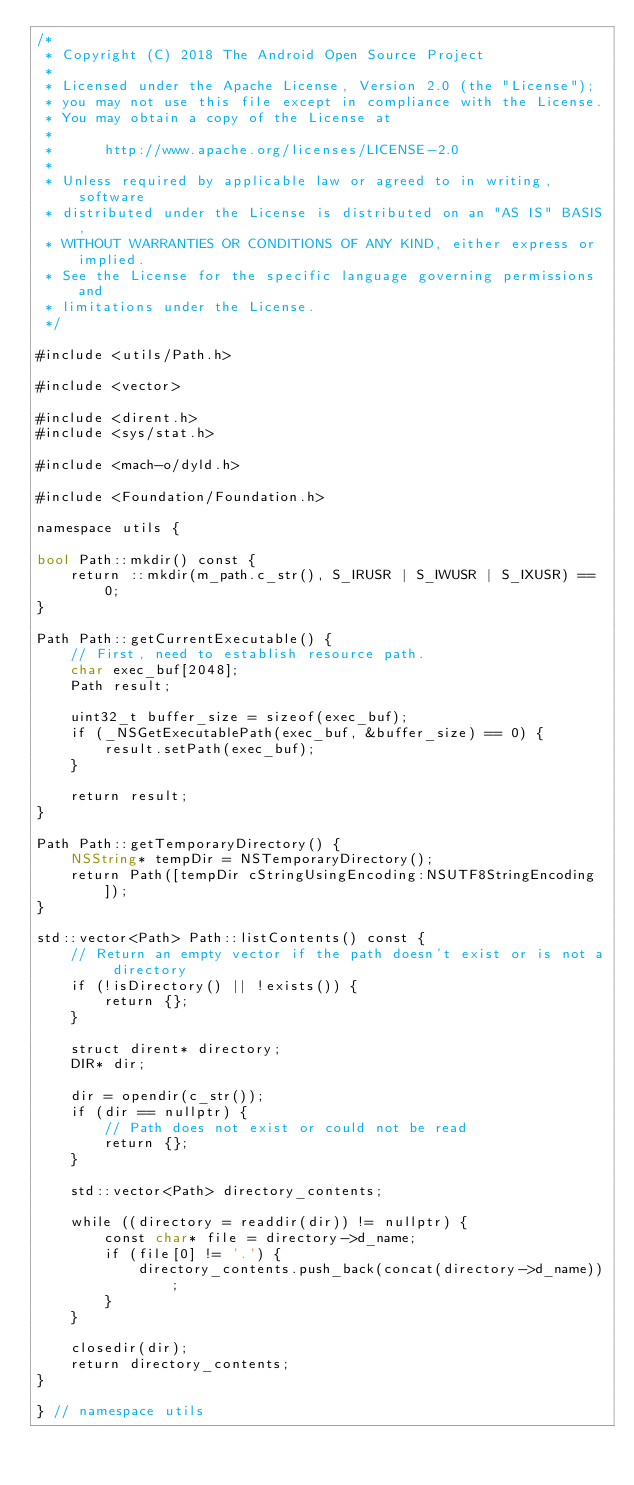<code> <loc_0><loc_0><loc_500><loc_500><_ObjectiveC_>/*
 * Copyright (C) 2018 The Android Open Source Project
 *
 * Licensed under the Apache License, Version 2.0 (the "License");
 * you may not use this file except in compliance with the License.
 * You may obtain a copy of the License at
 *
 *      http://www.apache.org/licenses/LICENSE-2.0
 *
 * Unless required by applicable law or agreed to in writing, software
 * distributed under the License is distributed on an "AS IS" BASIS,
 * WITHOUT WARRANTIES OR CONDITIONS OF ANY KIND, either express or implied.
 * See the License for the specific language governing permissions and
 * limitations under the License.
 */

#include <utils/Path.h>

#include <vector>

#include <dirent.h>
#include <sys/stat.h>

#include <mach-o/dyld.h>

#include <Foundation/Foundation.h>

namespace utils {

bool Path::mkdir() const {
    return ::mkdir(m_path.c_str(), S_IRUSR | S_IWUSR | S_IXUSR) == 0;
}

Path Path::getCurrentExecutable() {
    // First, need to establish resource path.
    char exec_buf[2048];
    Path result;

    uint32_t buffer_size = sizeof(exec_buf);
    if (_NSGetExecutablePath(exec_buf, &buffer_size) == 0) {
        result.setPath(exec_buf);
    }

    return result;
}

Path Path::getTemporaryDirectory() {
    NSString* tempDir = NSTemporaryDirectory();
    return Path([tempDir cStringUsingEncoding:NSUTF8StringEncoding]);
}

std::vector<Path> Path::listContents() const {
    // Return an empty vector if the path doesn't exist or is not a directory
    if (!isDirectory() || !exists()) {
        return {};
    }

    struct dirent* directory;
    DIR* dir;

    dir = opendir(c_str());
    if (dir == nullptr) {
        // Path does not exist or could not be read
        return {};
    }

    std::vector<Path> directory_contents;

    while ((directory = readdir(dir)) != nullptr) {
        const char* file = directory->d_name;
        if (file[0] != '.') {
            directory_contents.push_back(concat(directory->d_name));
        }
    }

    closedir(dir);
    return directory_contents;
}

} // namespace utils
</code> 